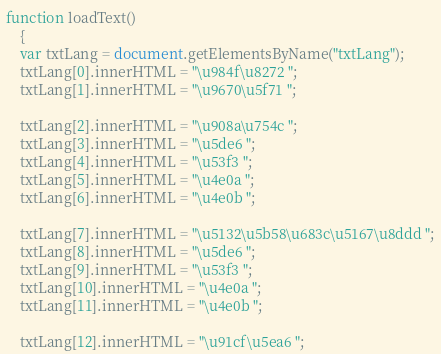Convert code to text. <code><loc_0><loc_0><loc_500><loc_500><_JavaScript_>function loadText()
    {
    var txtLang = document.getElementsByName("txtLang");
    txtLang[0].innerHTML = "\u984f\u8272 ";
    txtLang[1].innerHTML = "\u9670\u5f71 ";   
    
    txtLang[2].innerHTML = "\u908a\u754c ";
    txtLang[3].innerHTML = "\u5de6 ";
    txtLang[4].innerHTML = "\u53f3 ";
    txtLang[5].innerHTML = "\u4e0a ";
    txtLang[6].innerHTML = "\u4e0b ";
    
    txtLang[7].innerHTML = "\u5132\u5b58\u683c\u5167\u8ddd ";
    txtLang[8].innerHTML = "\u5de6 ";
    txtLang[9].innerHTML = "\u53f3 ";
    txtLang[10].innerHTML = "\u4e0a ";
    txtLang[11].innerHTML = "\u4e0b ";
    
    txtLang[12].innerHTML = "\u91cf\u5ea6 ";</code> 